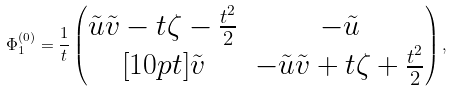<formula> <loc_0><loc_0><loc_500><loc_500>\Phi ^ { ( 0 ) } _ { 1 } = \frac { 1 } { t } \begin{pmatrix} \tilde { u } \tilde { v } - t \zeta - \frac { t ^ { 2 } } { 2 } & - \tilde { u } \\ [ 1 0 p t ] \tilde { v } & - \tilde { u } \tilde { v } + t \zeta + \frac { t ^ { 2 } } { 2 } \end{pmatrix} ,</formula> 